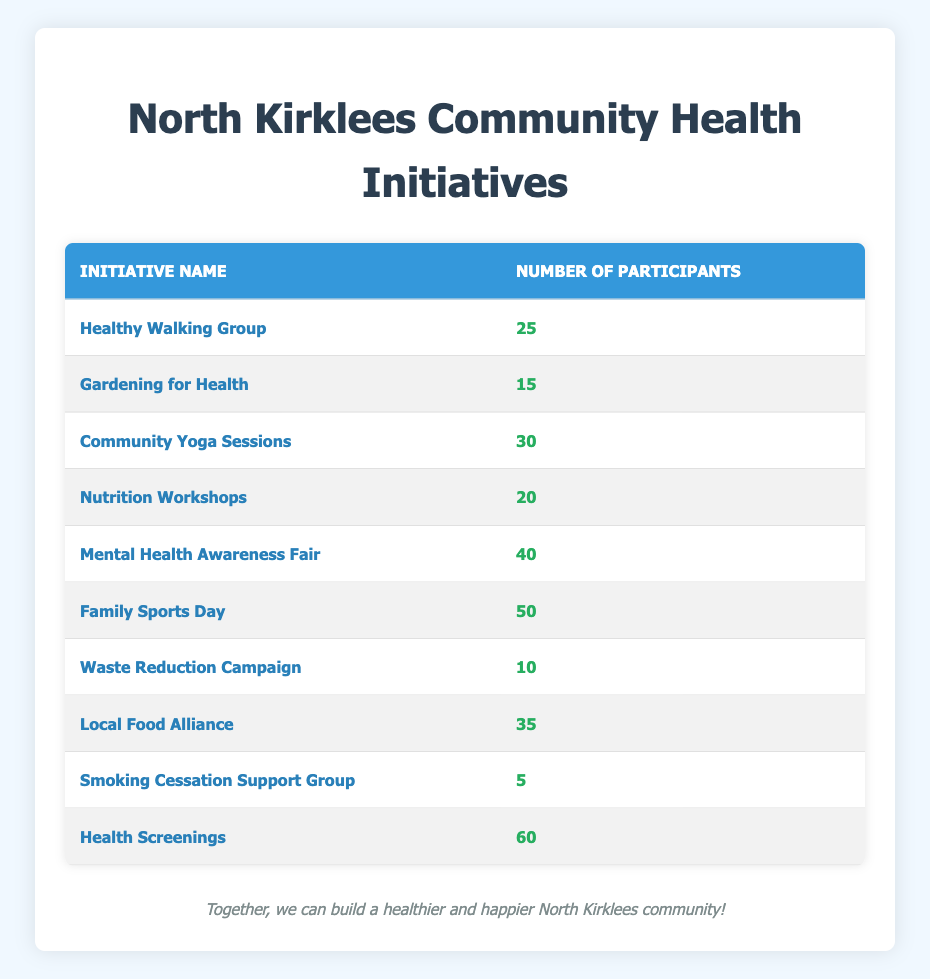What is the initiative with the highest number of participants? The table lists the number of participants for each initiative. By comparing the values, "Health Screenings" has the highest number of participants at 60.
Answer: Health Screenings How many participants are in the "Family Sports Day" initiative? The table shows that "Family Sports Day" has 50 participants listed alongside its name.
Answer: 50 What is the total number of participants across all initiatives? To find the total, add up the number of participants from each initiative: 25 + 15 + 30 + 20 + 40 + 50 + 10 + 35 + 5 + 60 = 290.
Answer: 290 Is the "Smoking Cessation Support Group" well-attended compared to other initiatives? "Smoking Cessation Support Group" has only 5 participants, which is the lowest among all initiatives, suggesting poor attendance.
Answer: No What is the average number of participants per initiative? There are 10 initiatives listed, and their total participants is 290. To find the average, divide the total by the number of initiatives: 290 / 10 = 29.
Answer: 29 Which initiative has fewer participants: "Gardening for Health" or "Nutrition Workshops"? Comparing the two initiatives, "Gardening for Health" has 15 participants, while "Nutrition Workshops" has 20 participants, making "Gardening for Health" the one with fewer participants.
Answer: Gardening for Health How many initiatives have more than 25 participants? Reviewing the table, the initiatives with more than 25 participants are: Community Yoga Sessions (30), Mental Health Awareness Fair (40), Family Sports Day (50), Local Food Alliance (35), and Health Screenings (60). That's a total of 5 initiatives.
Answer: 5 What is the difference in the number of participants between the highest and lowest attended initiatives? The highest attended initiative is "Health Screenings" with 60 participants and the lowest is "Smoking Cessation Support Group" with 5 participants. The difference is 60 - 5 = 55 participants.
Answer: 55 How many initiatives have between 15 and 40 participants? The initiatives that fall within this range are: Gardening for Health (15), Nutrition Workshops (20), Community Yoga Sessions (30), Local Food Alliance (35), and Mental Health Awareness Fair (40). That totals to 5 initiatives.
Answer: 5 